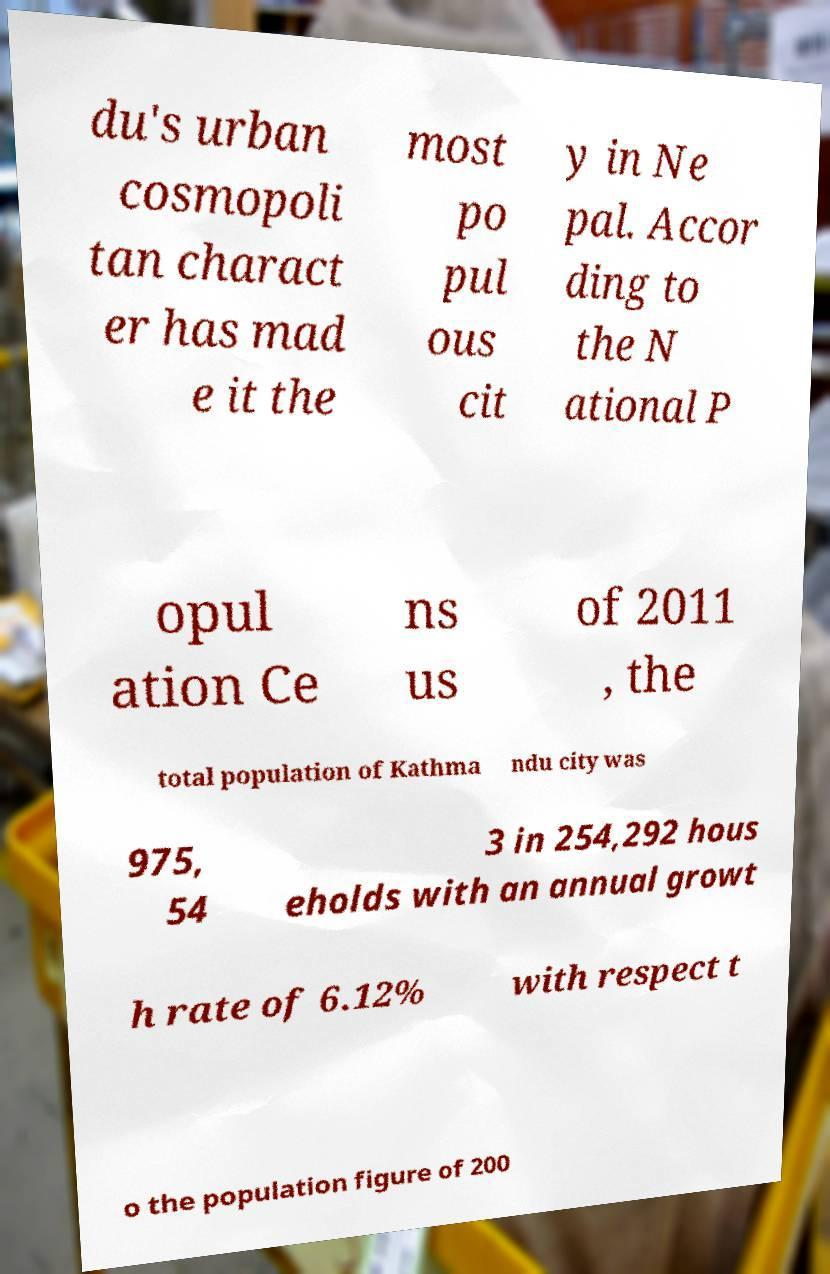For documentation purposes, I need the text within this image transcribed. Could you provide that? du's urban cosmopoli tan charact er has mad e it the most po pul ous cit y in Ne pal. Accor ding to the N ational P opul ation Ce ns us of 2011 , the total population of Kathma ndu city was 975, 54 3 in 254,292 hous eholds with an annual growt h rate of 6.12% with respect t o the population figure of 200 